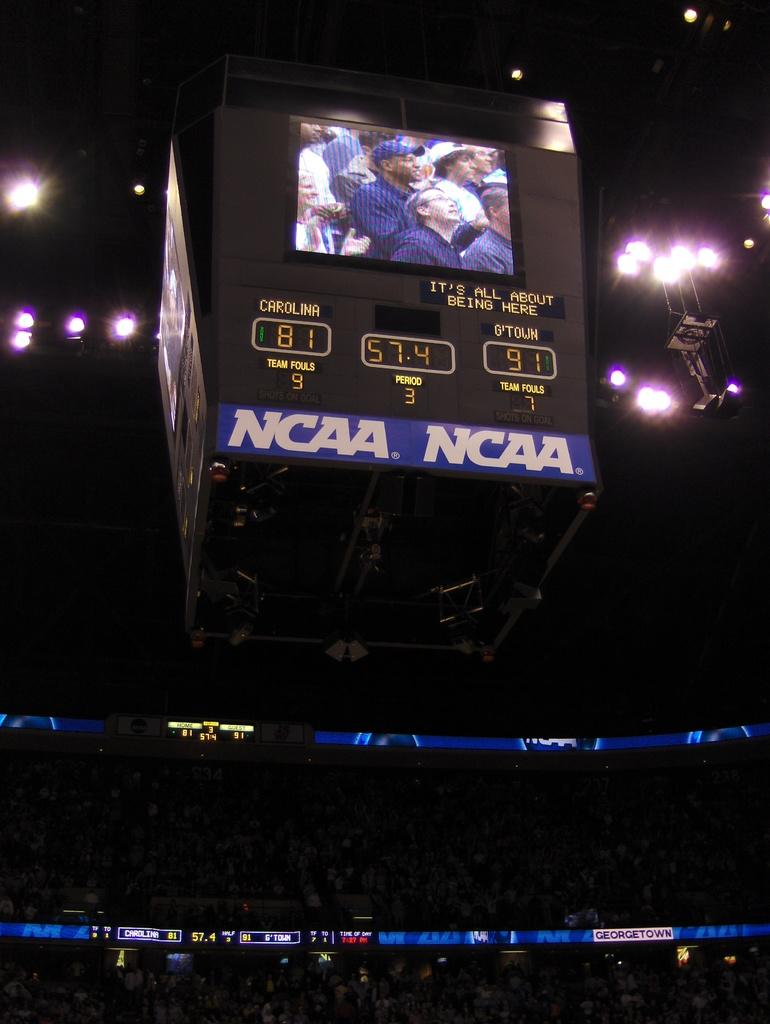<image>
Write a terse but informative summary of the picture. A projector screen showing the crowd on a screen with the NCAA logo below 